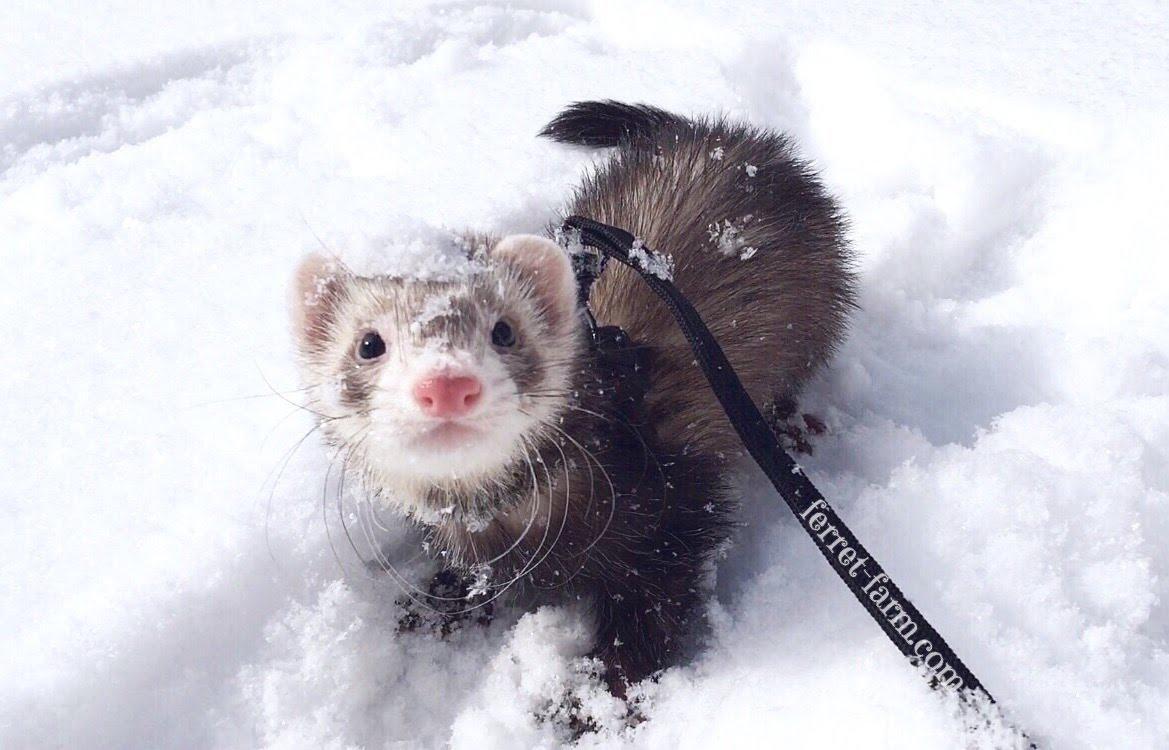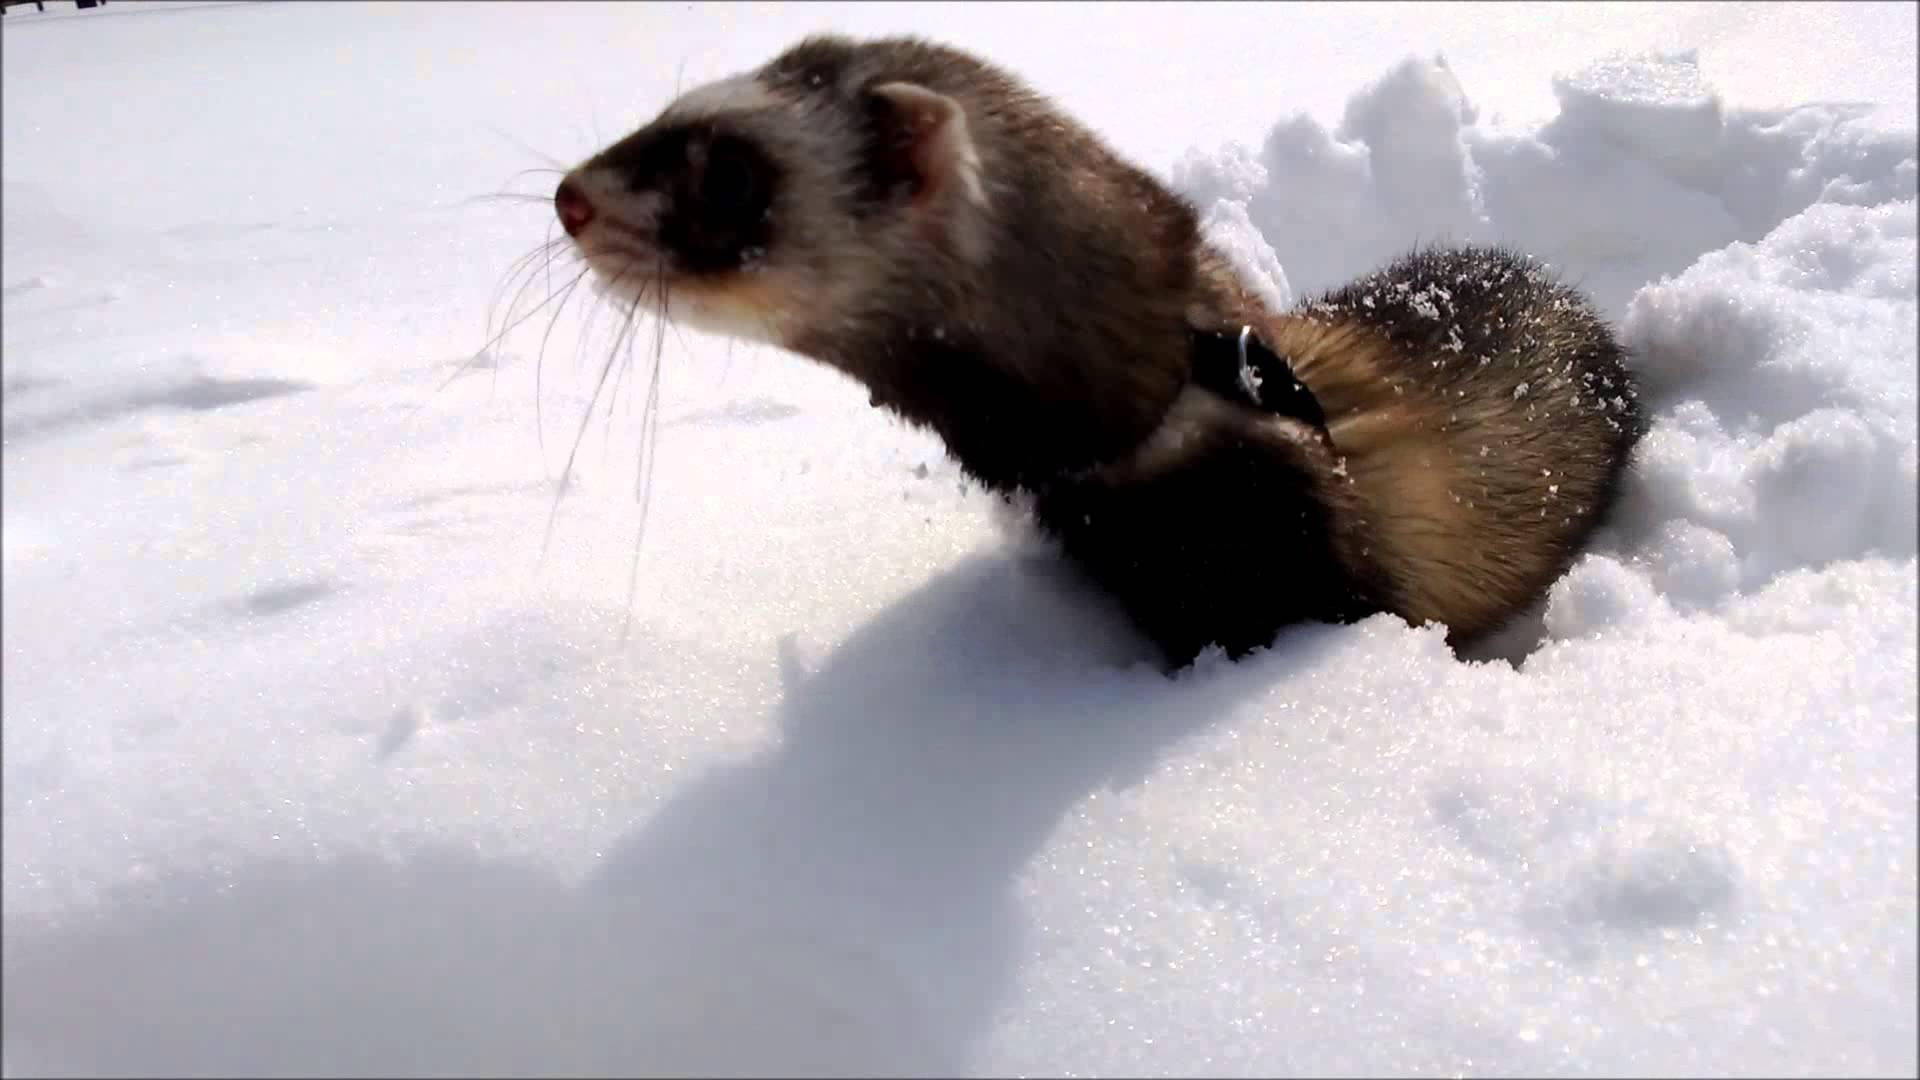The first image is the image on the left, the second image is the image on the right. Evaluate the accuracy of this statement regarding the images: "The right image has a ferret peeking out of the snow.". Is it true? Answer yes or no. Yes. The first image is the image on the left, the second image is the image on the right. Considering the images on both sides, is "The animal in the right image is not in the snow." valid? Answer yes or no. No. 